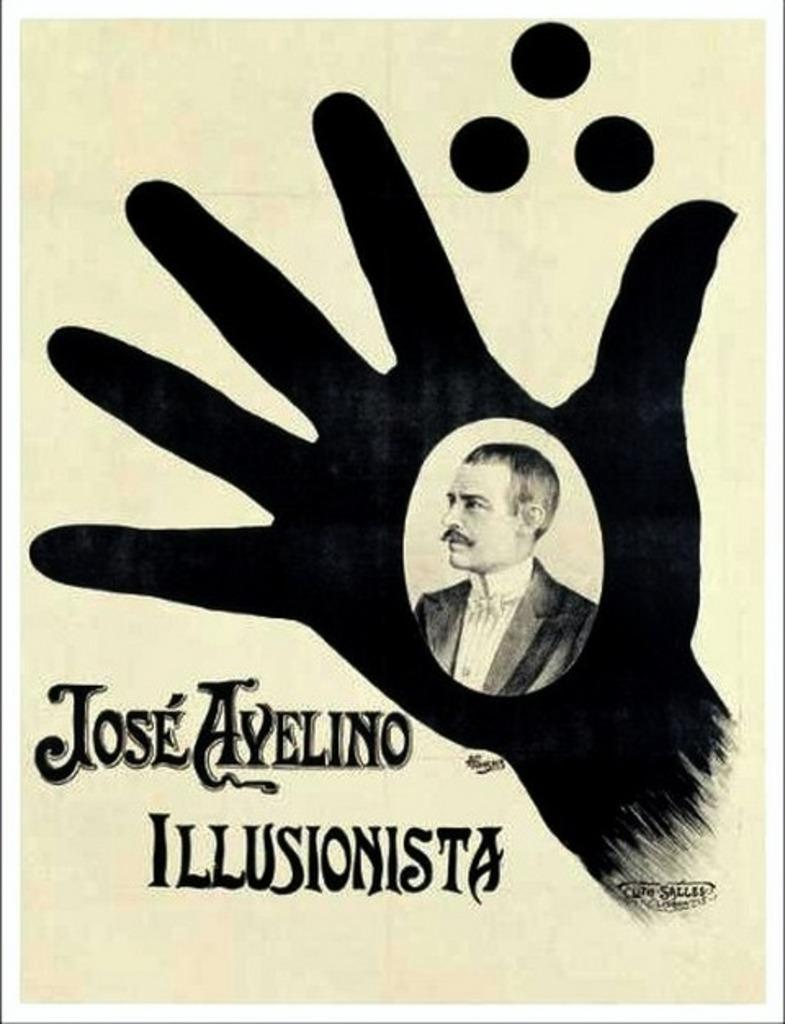What is featured on the poster in the image? The poster contains a picture of a person and a hand. What else can be found on the poster besides the images? There is text written on the poster. How many pancakes are being held by the person in the image? There is no person holding pancakes in the image; the poster contains a picture of a person and a hand, but no pancakes are visible. 